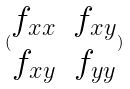<formula> <loc_0><loc_0><loc_500><loc_500>( \begin{matrix} f _ { x x } & f _ { x y } \\ f _ { x y } & f _ { y y } \end{matrix} )</formula> 